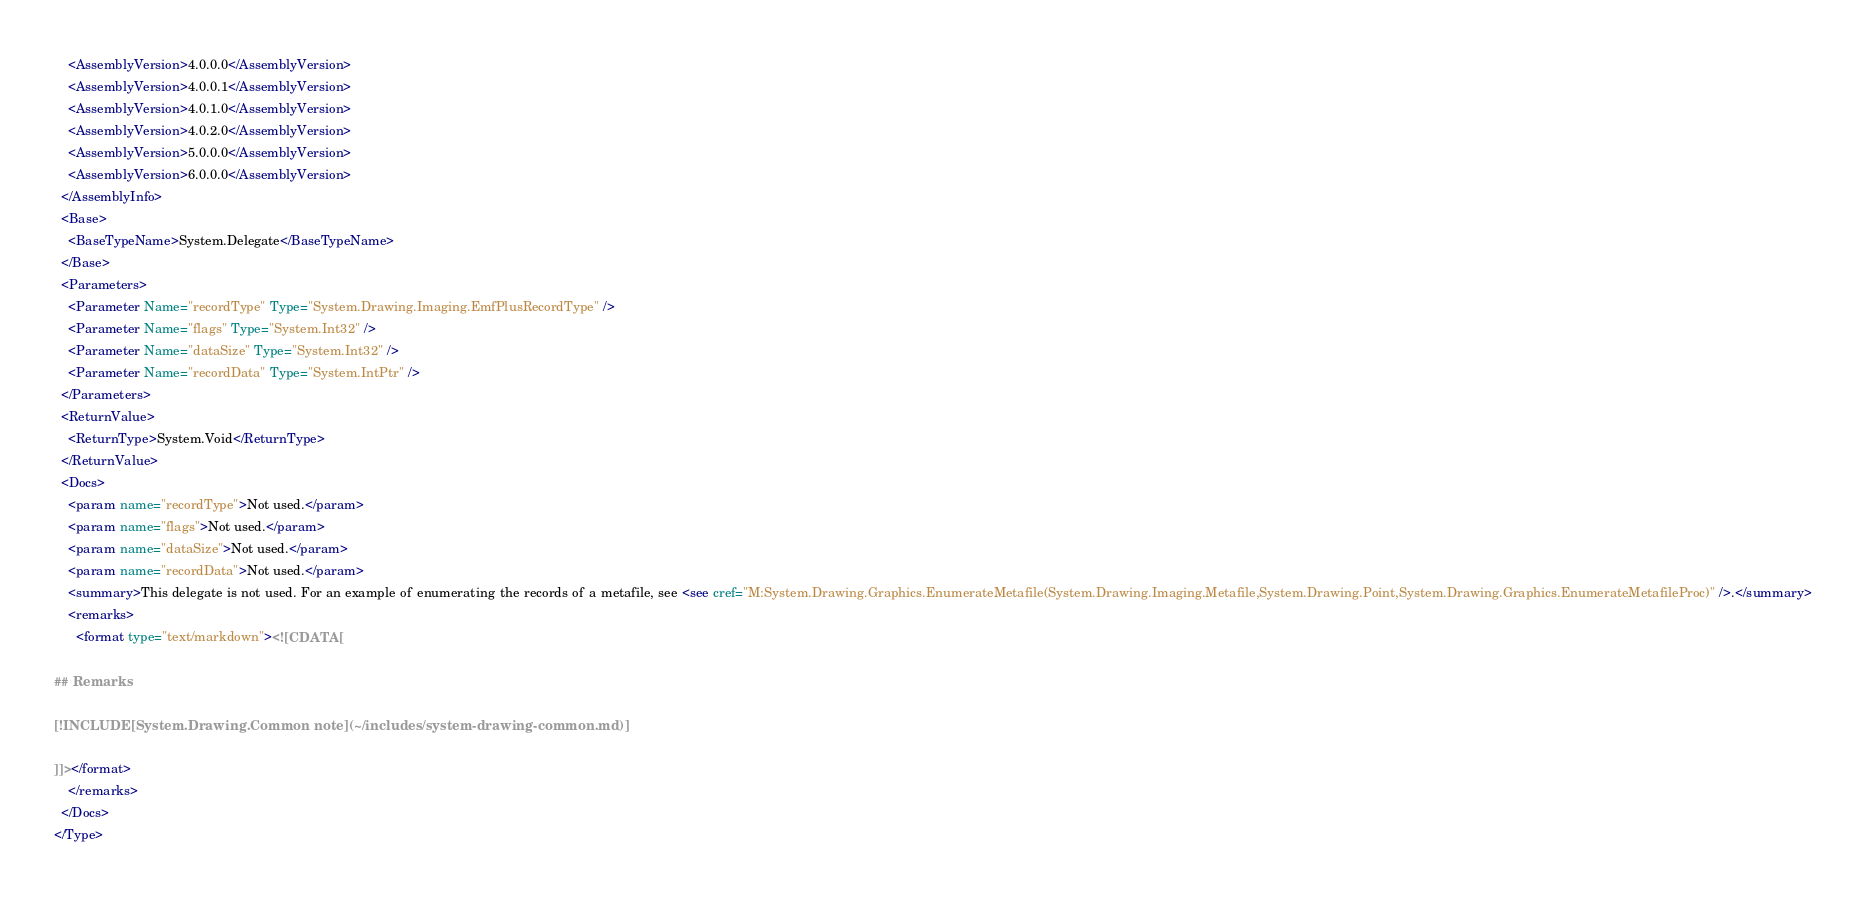<code> <loc_0><loc_0><loc_500><loc_500><_XML_>    <AssemblyVersion>4.0.0.0</AssemblyVersion>
    <AssemblyVersion>4.0.0.1</AssemblyVersion>
    <AssemblyVersion>4.0.1.0</AssemblyVersion>
    <AssemblyVersion>4.0.2.0</AssemblyVersion>
    <AssemblyVersion>5.0.0.0</AssemblyVersion>
    <AssemblyVersion>6.0.0.0</AssemblyVersion>
  </AssemblyInfo>
  <Base>
    <BaseTypeName>System.Delegate</BaseTypeName>
  </Base>
  <Parameters>
    <Parameter Name="recordType" Type="System.Drawing.Imaging.EmfPlusRecordType" />
    <Parameter Name="flags" Type="System.Int32" />
    <Parameter Name="dataSize" Type="System.Int32" />
    <Parameter Name="recordData" Type="System.IntPtr" />
  </Parameters>
  <ReturnValue>
    <ReturnType>System.Void</ReturnType>
  </ReturnValue>
  <Docs>
    <param name="recordType">Not used.</param>
    <param name="flags">Not used.</param>
    <param name="dataSize">Not used.</param>
    <param name="recordData">Not used.</param>
    <summary>This delegate is not used. For an example of enumerating the records of a metafile, see <see cref="M:System.Drawing.Graphics.EnumerateMetafile(System.Drawing.Imaging.Metafile,System.Drawing.Point,System.Drawing.Graphics.EnumerateMetafileProc)" />.</summary>
    <remarks>
      <format type="text/markdown"><![CDATA[

## Remarks

[!INCLUDE[System.Drawing.Common note](~/includes/system-drawing-common.md)]

]]></format>
    </remarks>
  </Docs>
</Type>
</code> 